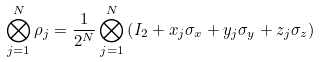Convert formula to latex. <formula><loc_0><loc_0><loc_500><loc_500>\bigotimes ^ { N } _ { j = 1 } \rho _ { j } = \frac { 1 } { 2 ^ { N } } \bigotimes ^ { N } _ { j = 1 } \left ( I _ { 2 } + x _ { j } \sigma _ { x } + y _ { j } \sigma _ { y } + z _ { j } \sigma _ { z } \right )</formula> 